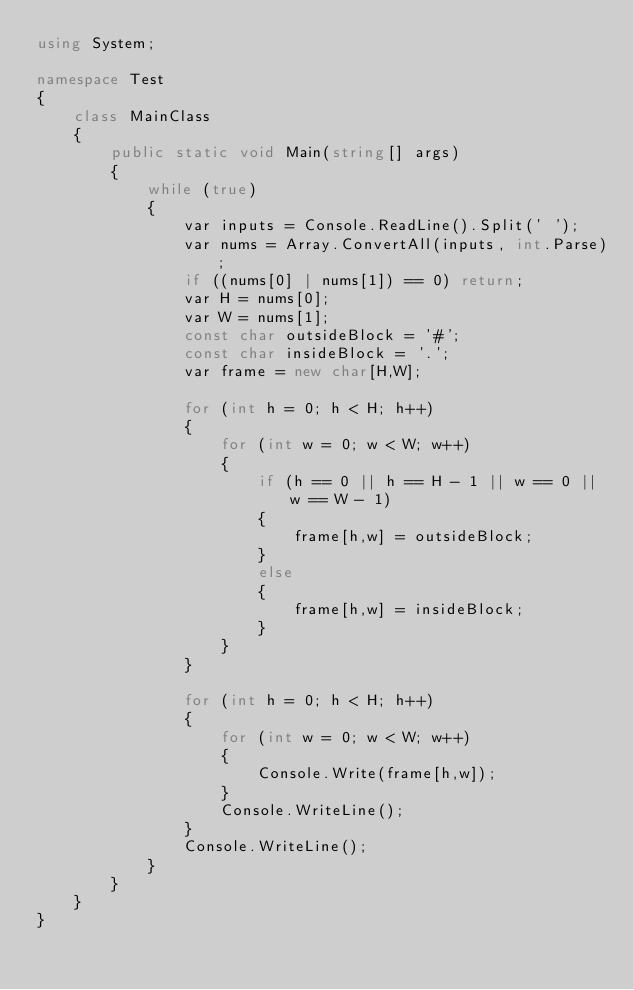<code> <loc_0><loc_0><loc_500><loc_500><_C#_>using System;

namespace Test
{
    class MainClass
    {
        public static void Main(string[] args)
        {
            while (true)
            {
                var inputs = Console.ReadLine().Split(' ');
                var nums = Array.ConvertAll(inputs, int.Parse);
                if ((nums[0] | nums[1]) == 0) return;
                var H = nums[0];
                var W = nums[1];
                const char outsideBlock = '#';
                const char insideBlock = '.';
                var frame = new char[H,W];

                for (int h = 0; h < H; h++)
                {
                    for (int w = 0; w < W; w++)
                    {
                        if (h == 0 || h == H - 1 || w == 0 || w == W - 1)
                        {
                            frame[h,w] = outsideBlock;
                        }
                        else
                        {
                            frame[h,w] = insideBlock;
                        }
                    }
                }

                for (int h = 0; h < H; h++)
                {
                    for (int w = 0; w < W; w++)
                    {
                        Console.Write(frame[h,w]);
                    }
                    Console.WriteLine();
                }
                Console.WriteLine();
            }
        }
    }
}</code> 